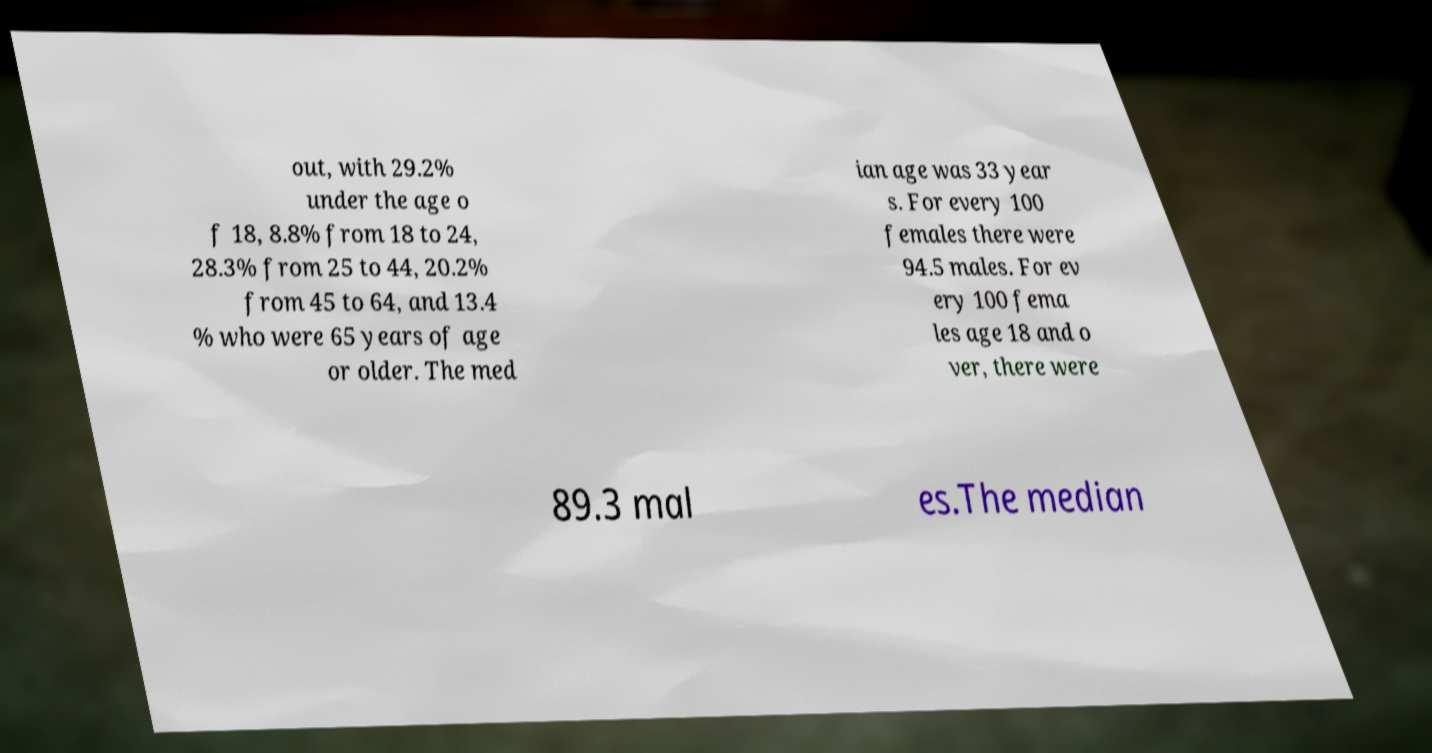Could you extract and type out the text from this image? out, with 29.2% under the age o f 18, 8.8% from 18 to 24, 28.3% from 25 to 44, 20.2% from 45 to 64, and 13.4 % who were 65 years of age or older. The med ian age was 33 year s. For every 100 females there were 94.5 males. For ev ery 100 fema les age 18 and o ver, there were 89.3 mal es.The median 